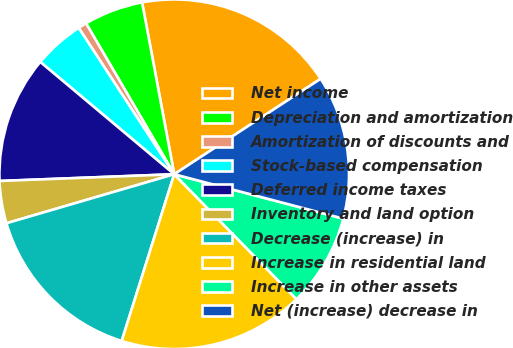Convert chart. <chart><loc_0><loc_0><loc_500><loc_500><pie_chart><fcel>Net income<fcel>Depreciation and amortization<fcel>Amortization of discounts and<fcel>Stock-based compensation<fcel>Deferred income taxes<fcel>Inventory and land option<fcel>Decrease (increase) in<fcel>Increase in residential land<fcel>Increase in other assets<fcel>Net (increase) decrease in<nl><fcel>18.75%<fcel>5.47%<fcel>0.79%<fcel>4.69%<fcel>11.72%<fcel>3.91%<fcel>15.62%<fcel>17.18%<fcel>8.59%<fcel>13.28%<nl></chart> 